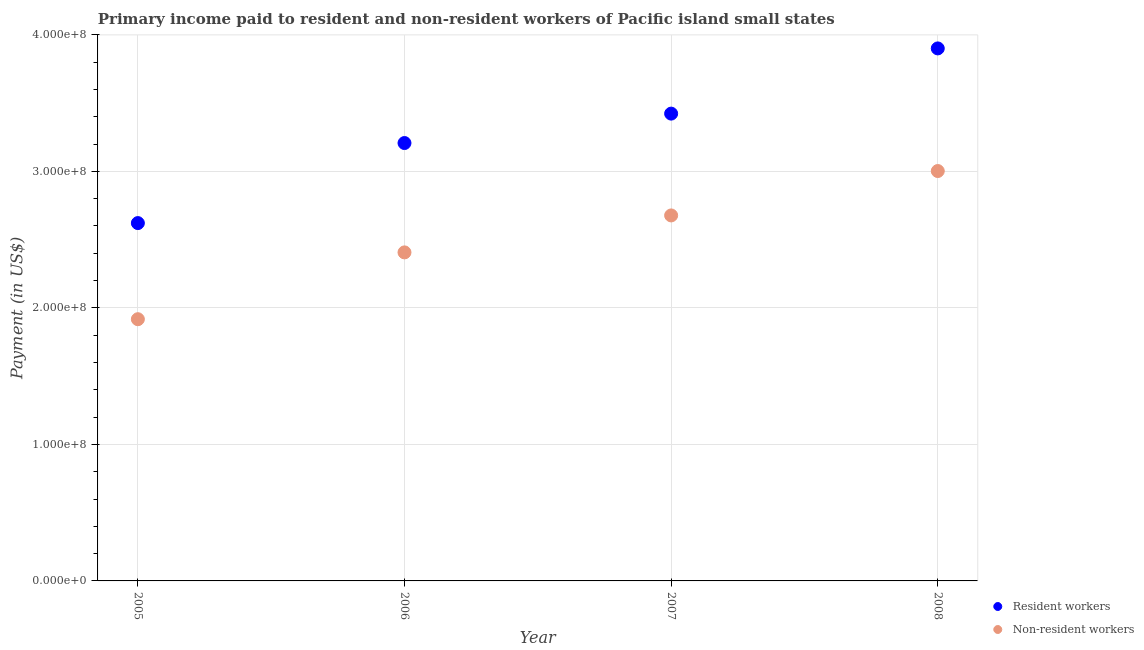How many different coloured dotlines are there?
Provide a succinct answer. 2. What is the payment made to non-resident workers in 2008?
Give a very brief answer. 3.00e+08. Across all years, what is the maximum payment made to resident workers?
Make the answer very short. 3.90e+08. Across all years, what is the minimum payment made to resident workers?
Provide a succinct answer. 2.62e+08. In which year was the payment made to resident workers maximum?
Your answer should be very brief. 2008. What is the total payment made to non-resident workers in the graph?
Ensure brevity in your answer.  1.00e+09. What is the difference between the payment made to non-resident workers in 2005 and that in 2006?
Keep it short and to the point. -4.89e+07. What is the difference between the payment made to resident workers in 2007 and the payment made to non-resident workers in 2008?
Your answer should be compact. 4.21e+07. What is the average payment made to non-resident workers per year?
Make the answer very short. 2.50e+08. In the year 2006, what is the difference between the payment made to non-resident workers and payment made to resident workers?
Your response must be concise. -8.01e+07. What is the ratio of the payment made to non-resident workers in 2006 to that in 2007?
Your response must be concise. 0.9. Is the payment made to non-resident workers in 2005 less than that in 2007?
Provide a succinct answer. Yes. Is the difference between the payment made to resident workers in 2007 and 2008 greater than the difference between the payment made to non-resident workers in 2007 and 2008?
Your answer should be very brief. No. What is the difference between the highest and the second highest payment made to resident workers?
Ensure brevity in your answer.  4.78e+07. What is the difference between the highest and the lowest payment made to non-resident workers?
Your answer should be compact. 1.09e+08. In how many years, is the payment made to resident workers greater than the average payment made to resident workers taken over all years?
Your answer should be compact. 2. Is the sum of the payment made to non-resident workers in 2005 and 2006 greater than the maximum payment made to resident workers across all years?
Your response must be concise. Yes. Does the payment made to non-resident workers monotonically increase over the years?
Your response must be concise. Yes. Is the payment made to resident workers strictly less than the payment made to non-resident workers over the years?
Provide a succinct answer. No. How many dotlines are there?
Your answer should be compact. 2. Are the values on the major ticks of Y-axis written in scientific E-notation?
Provide a short and direct response. Yes. How many legend labels are there?
Provide a succinct answer. 2. What is the title of the graph?
Provide a succinct answer. Primary income paid to resident and non-resident workers of Pacific island small states. Does "Domestic Liabilities" appear as one of the legend labels in the graph?
Ensure brevity in your answer.  No. What is the label or title of the X-axis?
Your answer should be compact. Year. What is the label or title of the Y-axis?
Ensure brevity in your answer.  Payment (in US$). What is the Payment (in US$) in Resident workers in 2005?
Provide a succinct answer. 2.62e+08. What is the Payment (in US$) of Non-resident workers in 2005?
Keep it short and to the point. 1.92e+08. What is the Payment (in US$) of Resident workers in 2006?
Your response must be concise. 3.21e+08. What is the Payment (in US$) of Non-resident workers in 2006?
Your answer should be compact. 2.41e+08. What is the Payment (in US$) of Resident workers in 2007?
Make the answer very short. 3.42e+08. What is the Payment (in US$) in Non-resident workers in 2007?
Make the answer very short. 2.68e+08. What is the Payment (in US$) in Resident workers in 2008?
Ensure brevity in your answer.  3.90e+08. What is the Payment (in US$) of Non-resident workers in 2008?
Provide a succinct answer. 3.00e+08. Across all years, what is the maximum Payment (in US$) of Resident workers?
Your answer should be compact. 3.90e+08. Across all years, what is the maximum Payment (in US$) of Non-resident workers?
Your answer should be very brief. 3.00e+08. Across all years, what is the minimum Payment (in US$) of Resident workers?
Give a very brief answer. 2.62e+08. Across all years, what is the minimum Payment (in US$) of Non-resident workers?
Give a very brief answer. 1.92e+08. What is the total Payment (in US$) of Resident workers in the graph?
Provide a succinct answer. 1.32e+09. What is the total Payment (in US$) of Non-resident workers in the graph?
Offer a very short reply. 1.00e+09. What is the difference between the Payment (in US$) in Resident workers in 2005 and that in 2006?
Offer a very short reply. -5.86e+07. What is the difference between the Payment (in US$) of Non-resident workers in 2005 and that in 2006?
Offer a very short reply. -4.89e+07. What is the difference between the Payment (in US$) of Resident workers in 2005 and that in 2007?
Offer a very short reply. -8.02e+07. What is the difference between the Payment (in US$) in Non-resident workers in 2005 and that in 2007?
Provide a short and direct response. -7.60e+07. What is the difference between the Payment (in US$) of Resident workers in 2005 and that in 2008?
Your answer should be very brief. -1.28e+08. What is the difference between the Payment (in US$) in Non-resident workers in 2005 and that in 2008?
Your response must be concise. -1.09e+08. What is the difference between the Payment (in US$) of Resident workers in 2006 and that in 2007?
Your response must be concise. -2.16e+07. What is the difference between the Payment (in US$) in Non-resident workers in 2006 and that in 2007?
Provide a succinct answer. -2.71e+07. What is the difference between the Payment (in US$) of Resident workers in 2006 and that in 2008?
Keep it short and to the point. -6.93e+07. What is the difference between the Payment (in US$) of Non-resident workers in 2006 and that in 2008?
Your answer should be very brief. -5.96e+07. What is the difference between the Payment (in US$) of Resident workers in 2007 and that in 2008?
Your response must be concise. -4.78e+07. What is the difference between the Payment (in US$) of Non-resident workers in 2007 and that in 2008?
Provide a short and direct response. -3.25e+07. What is the difference between the Payment (in US$) of Resident workers in 2005 and the Payment (in US$) of Non-resident workers in 2006?
Offer a terse response. 2.15e+07. What is the difference between the Payment (in US$) in Resident workers in 2005 and the Payment (in US$) in Non-resident workers in 2007?
Your response must be concise. -5.61e+06. What is the difference between the Payment (in US$) of Resident workers in 2005 and the Payment (in US$) of Non-resident workers in 2008?
Provide a succinct answer. -3.81e+07. What is the difference between the Payment (in US$) of Resident workers in 2006 and the Payment (in US$) of Non-resident workers in 2007?
Offer a terse response. 5.30e+07. What is the difference between the Payment (in US$) in Resident workers in 2006 and the Payment (in US$) in Non-resident workers in 2008?
Provide a succinct answer. 2.05e+07. What is the difference between the Payment (in US$) in Resident workers in 2007 and the Payment (in US$) in Non-resident workers in 2008?
Provide a succinct answer. 4.21e+07. What is the average Payment (in US$) in Resident workers per year?
Your answer should be compact. 3.29e+08. What is the average Payment (in US$) in Non-resident workers per year?
Keep it short and to the point. 2.50e+08. In the year 2005, what is the difference between the Payment (in US$) in Resident workers and Payment (in US$) in Non-resident workers?
Offer a terse response. 7.04e+07. In the year 2006, what is the difference between the Payment (in US$) of Resident workers and Payment (in US$) of Non-resident workers?
Give a very brief answer. 8.01e+07. In the year 2007, what is the difference between the Payment (in US$) of Resident workers and Payment (in US$) of Non-resident workers?
Your answer should be compact. 7.46e+07. In the year 2008, what is the difference between the Payment (in US$) in Resident workers and Payment (in US$) in Non-resident workers?
Offer a very short reply. 8.98e+07. What is the ratio of the Payment (in US$) in Resident workers in 2005 to that in 2006?
Make the answer very short. 0.82. What is the ratio of the Payment (in US$) in Non-resident workers in 2005 to that in 2006?
Give a very brief answer. 0.8. What is the ratio of the Payment (in US$) in Resident workers in 2005 to that in 2007?
Your answer should be compact. 0.77. What is the ratio of the Payment (in US$) of Non-resident workers in 2005 to that in 2007?
Keep it short and to the point. 0.72. What is the ratio of the Payment (in US$) in Resident workers in 2005 to that in 2008?
Give a very brief answer. 0.67. What is the ratio of the Payment (in US$) in Non-resident workers in 2005 to that in 2008?
Provide a short and direct response. 0.64. What is the ratio of the Payment (in US$) of Resident workers in 2006 to that in 2007?
Provide a short and direct response. 0.94. What is the ratio of the Payment (in US$) of Non-resident workers in 2006 to that in 2007?
Keep it short and to the point. 0.9. What is the ratio of the Payment (in US$) of Resident workers in 2006 to that in 2008?
Provide a succinct answer. 0.82. What is the ratio of the Payment (in US$) of Non-resident workers in 2006 to that in 2008?
Give a very brief answer. 0.8. What is the ratio of the Payment (in US$) of Resident workers in 2007 to that in 2008?
Ensure brevity in your answer.  0.88. What is the ratio of the Payment (in US$) in Non-resident workers in 2007 to that in 2008?
Provide a succinct answer. 0.89. What is the difference between the highest and the second highest Payment (in US$) in Resident workers?
Make the answer very short. 4.78e+07. What is the difference between the highest and the second highest Payment (in US$) in Non-resident workers?
Provide a succinct answer. 3.25e+07. What is the difference between the highest and the lowest Payment (in US$) of Resident workers?
Offer a terse response. 1.28e+08. What is the difference between the highest and the lowest Payment (in US$) in Non-resident workers?
Provide a succinct answer. 1.09e+08. 